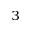Convert formula to latex. <formula><loc_0><loc_0><loc_500><loc_500>^ { 3 }</formula> 